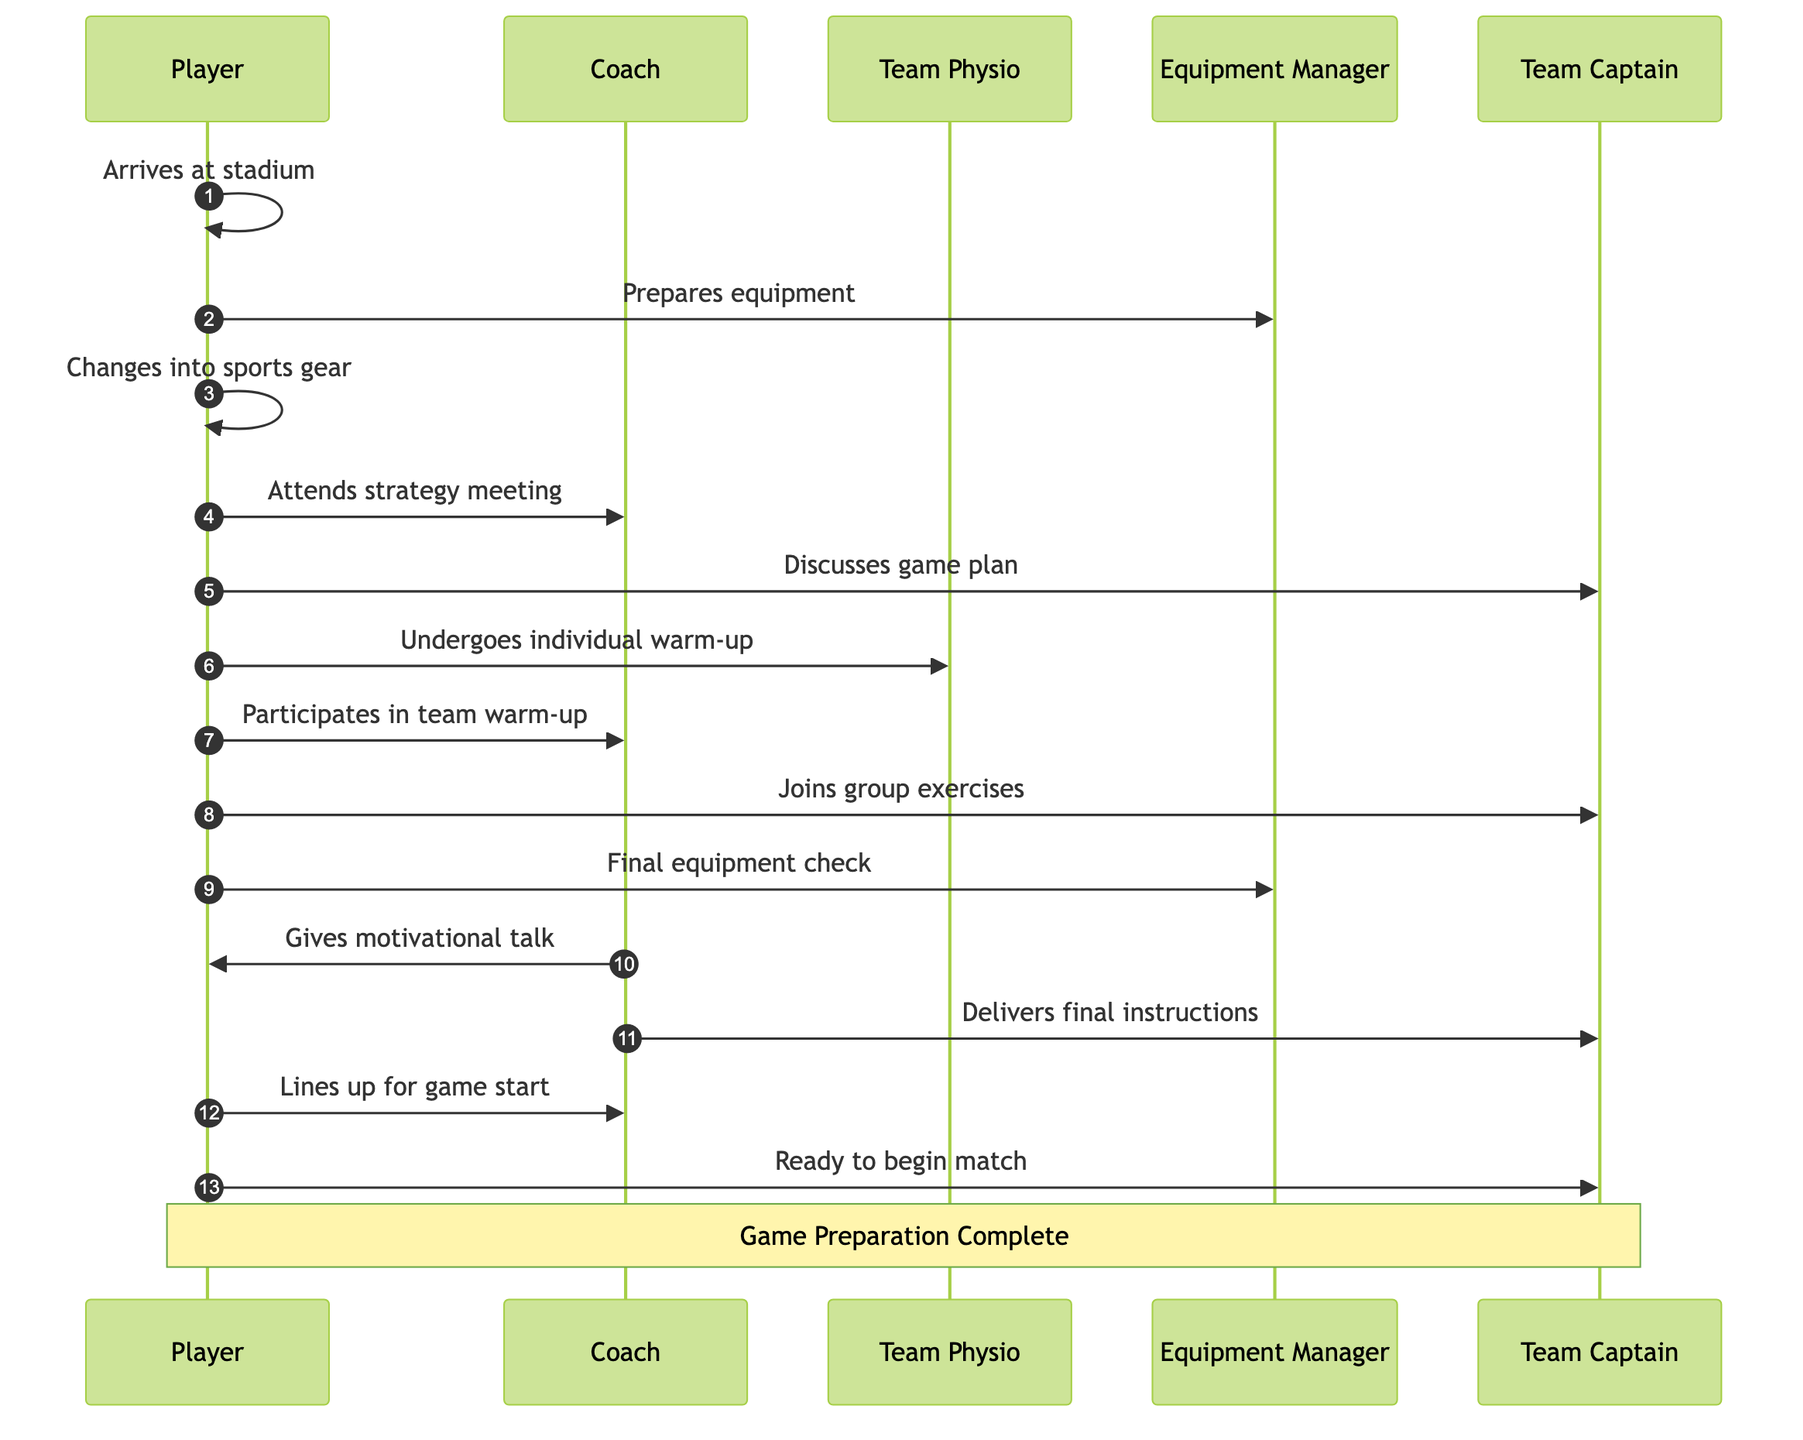What is the first action the player takes upon arriving at the stadium? The first action occurs when the player arrives at the stadium, as indicated by the message directly from Player to Player. This shows a self-referential action, meaning the player acknowledges their arrival.
Answer: Arrives at stadium How many participants are involved in the sequence diagram? The sequence diagram includes five participants: Player, Coach, Team Physio, Equipment Manager, and Team Captain. This can be determined by counting each distinct actor listed.
Answer: Five Which action involves discussing the game strategy? The action involving discussing the game strategy is represented as "Team Strategy Meeting", where the player interacts with the coach and team captain. This is explicitly stated in the interaction details of the sequence diagram.
Answer: Team Strategy Meeting What is the last action before lining up for the game? The last action before lining up for the game is the "Motivational Talk", where the coach gives a final motivational talk to the player, marking a crucial motivational step before the match begins. This is indicated by the sequence of interactions leading to the lineup.
Answer: Motivational Talk Which two actors are involved in the individual warm-up? The two actors involved in the individual warm-up are the Player and the Team Physio. The diagram clearly indicates this relationship through the interaction during this specific action, showing collaboration between the player and the physio for warm-up preparation.
Answer: Player and Team Physio What does the player do after the final equipment check? After the final equipment check, the player participates in the motivational talk given by the coach. This follows the sequence laid out in the diagram, indicating the structured progression of activities.
Answer: Participates in motivational talk Which action directly follows the group warm-up exercises? The action that directly follows the group warm-up exercises is the final equipment check. The sequence is linear, showing that after engagement in group exercises, checking equipment is the next crucial task.
Answer: Final equipment check How many interactions include the Team Captain? There are four interactions that include the Team Captain: Team Strategy Meeting, Team Warm-Up, Motivational Talk, and lining up. By reviewing each action in the sequence, we can determine the involvement of the Team Captain in four separate instances.
Answer: Four What role does the Equipment Manager play during the preparation? The Equipment Manager plays a crucial role in preparing and checking the player's equipment, which is highlighted in two distinct actions: Locker Room Preparation and Final Equipment Check. Their responsibility is centered around ensuring that all necessary gear is ready before the game.
Answer: Prepares and checks equipment 